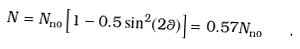Convert formula to latex. <formula><loc_0><loc_0><loc_500><loc_500>N = N _ { \text {no} } \left [ 1 - 0 . 5 \sin ^ { 2 } ( 2 \theta ) \right ] = 0 . 5 7 N _ { \text {no} } \quad .</formula> 